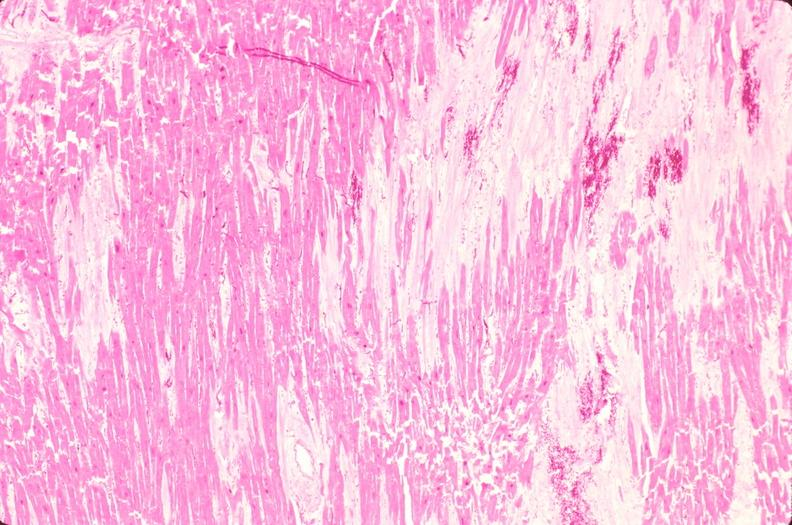does opened muscle show heart, old myocardial infarction with fibrosis, he?
Answer the question using a single word or phrase. No 